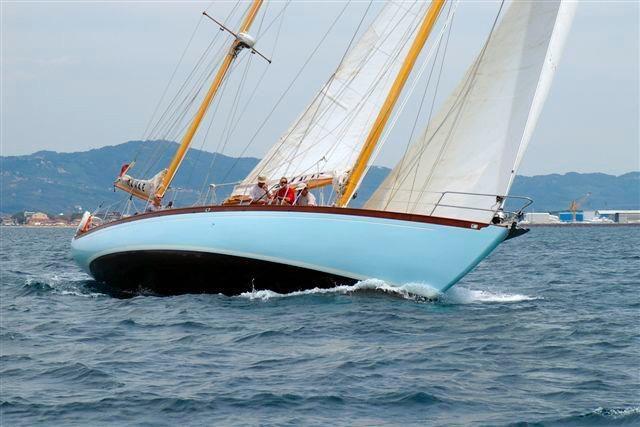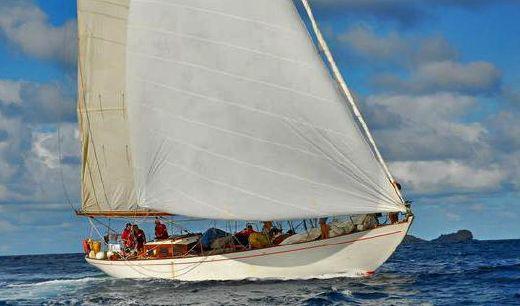The first image is the image on the left, the second image is the image on the right. Given the left and right images, does the statement "One of the images has a large group of people all wearing white shirts." hold true? Answer yes or no. No. 